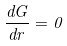<formula> <loc_0><loc_0><loc_500><loc_500>\frac { d G } { d r } = 0</formula> 